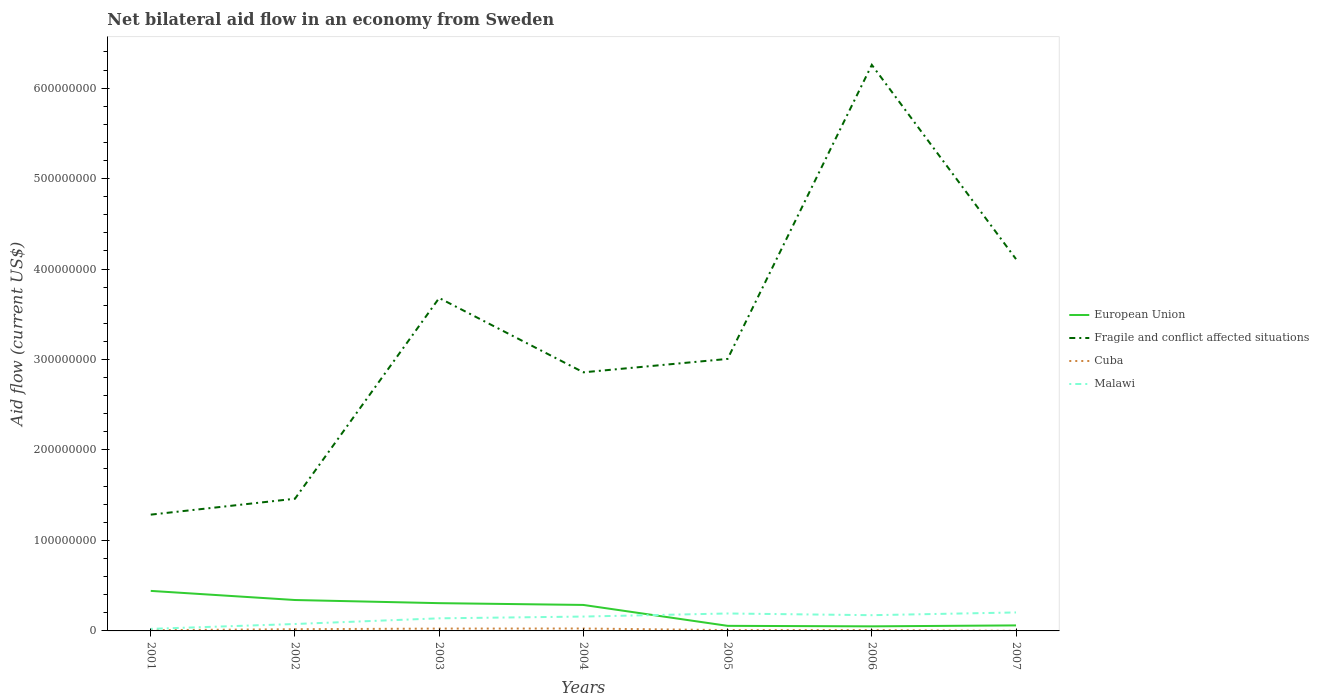Does the line corresponding to Fragile and conflict affected situations intersect with the line corresponding to European Union?
Keep it short and to the point. No. Across all years, what is the maximum net bilateral aid flow in European Union?
Offer a very short reply. 5.06e+06. In which year was the net bilateral aid flow in Cuba maximum?
Your answer should be compact. 2007. What is the total net bilateral aid flow in Cuba in the graph?
Provide a succinct answer. 1.74e+06. What is the difference between the highest and the second highest net bilateral aid flow in European Union?
Make the answer very short. 3.92e+07. What is the difference between the highest and the lowest net bilateral aid flow in Malawi?
Offer a terse response. 5. How many lines are there?
Your answer should be very brief. 4. Are the values on the major ticks of Y-axis written in scientific E-notation?
Offer a terse response. No. Does the graph contain any zero values?
Your response must be concise. No. Does the graph contain grids?
Offer a terse response. No. Where does the legend appear in the graph?
Offer a terse response. Center right. What is the title of the graph?
Offer a very short reply. Net bilateral aid flow in an economy from Sweden. Does "Andorra" appear as one of the legend labels in the graph?
Make the answer very short. No. What is the Aid flow (current US$) in European Union in 2001?
Give a very brief answer. 4.42e+07. What is the Aid flow (current US$) of Fragile and conflict affected situations in 2001?
Keep it short and to the point. 1.29e+08. What is the Aid flow (current US$) of Cuba in 2001?
Your response must be concise. 8.10e+05. What is the Aid flow (current US$) of Malawi in 2001?
Give a very brief answer. 2.27e+06. What is the Aid flow (current US$) of European Union in 2002?
Ensure brevity in your answer.  3.42e+07. What is the Aid flow (current US$) in Fragile and conflict affected situations in 2002?
Ensure brevity in your answer.  1.46e+08. What is the Aid flow (current US$) of Cuba in 2002?
Offer a very short reply. 1.89e+06. What is the Aid flow (current US$) of Malawi in 2002?
Offer a very short reply. 7.65e+06. What is the Aid flow (current US$) in European Union in 2003?
Your response must be concise. 3.07e+07. What is the Aid flow (current US$) of Fragile and conflict affected situations in 2003?
Keep it short and to the point. 3.68e+08. What is the Aid flow (current US$) in Cuba in 2003?
Your answer should be compact. 2.58e+06. What is the Aid flow (current US$) of Malawi in 2003?
Your answer should be compact. 1.39e+07. What is the Aid flow (current US$) in European Union in 2004?
Your response must be concise. 2.87e+07. What is the Aid flow (current US$) in Fragile and conflict affected situations in 2004?
Your response must be concise. 2.86e+08. What is the Aid flow (current US$) of Cuba in 2004?
Your answer should be compact. 2.66e+06. What is the Aid flow (current US$) of Malawi in 2004?
Provide a succinct answer. 1.59e+07. What is the Aid flow (current US$) in European Union in 2005?
Your response must be concise. 5.62e+06. What is the Aid flow (current US$) in Fragile and conflict affected situations in 2005?
Your answer should be very brief. 3.01e+08. What is the Aid flow (current US$) in Cuba in 2005?
Offer a terse response. 9.30e+05. What is the Aid flow (current US$) of Malawi in 2005?
Make the answer very short. 1.93e+07. What is the Aid flow (current US$) of European Union in 2006?
Your answer should be compact. 5.06e+06. What is the Aid flow (current US$) of Fragile and conflict affected situations in 2006?
Make the answer very short. 6.26e+08. What is the Aid flow (current US$) of Cuba in 2006?
Offer a very short reply. 9.20e+05. What is the Aid flow (current US$) of Malawi in 2006?
Your answer should be compact. 1.74e+07. What is the Aid flow (current US$) in European Union in 2007?
Keep it short and to the point. 6.10e+06. What is the Aid flow (current US$) of Fragile and conflict affected situations in 2007?
Your answer should be very brief. 4.11e+08. What is the Aid flow (current US$) in Cuba in 2007?
Provide a succinct answer. 1.10e+05. What is the Aid flow (current US$) in Malawi in 2007?
Keep it short and to the point. 2.04e+07. Across all years, what is the maximum Aid flow (current US$) in European Union?
Ensure brevity in your answer.  4.42e+07. Across all years, what is the maximum Aid flow (current US$) in Fragile and conflict affected situations?
Your response must be concise. 6.26e+08. Across all years, what is the maximum Aid flow (current US$) in Cuba?
Ensure brevity in your answer.  2.66e+06. Across all years, what is the maximum Aid flow (current US$) of Malawi?
Your response must be concise. 2.04e+07. Across all years, what is the minimum Aid flow (current US$) of European Union?
Give a very brief answer. 5.06e+06. Across all years, what is the minimum Aid flow (current US$) of Fragile and conflict affected situations?
Provide a succinct answer. 1.29e+08. Across all years, what is the minimum Aid flow (current US$) in Malawi?
Your answer should be very brief. 2.27e+06. What is the total Aid flow (current US$) in European Union in the graph?
Make the answer very short. 1.55e+08. What is the total Aid flow (current US$) of Fragile and conflict affected situations in the graph?
Ensure brevity in your answer.  2.27e+09. What is the total Aid flow (current US$) of Cuba in the graph?
Offer a very short reply. 9.90e+06. What is the total Aid flow (current US$) in Malawi in the graph?
Provide a succinct answer. 9.68e+07. What is the difference between the Aid flow (current US$) of European Union in 2001 and that in 2002?
Ensure brevity in your answer.  1.01e+07. What is the difference between the Aid flow (current US$) in Fragile and conflict affected situations in 2001 and that in 2002?
Ensure brevity in your answer.  -1.76e+07. What is the difference between the Aid flow (current US$) of Cuba in 2001 and that in 2002?
Ensure brevity in your answer.  -1.08e+06. What is the difference between the Aid flow (current US$) of Malawi in 2001 and that in 2002?
Your answer should be compact. -5.38e+06. What is the difference between the Aid flow (current US$) in European Union in 2001 and that in 2003?
Give a very brief answer. 1.36e+07. What is the difference between the Aid flow (current US$) of Fragile and conflict affected situations in 2001 and that in 2003?
Offer a very short reply. -2.39e+08. What is the difference between the Aid flow (current US$) in Cuba in 2001 and that in 2003?
Keep it short and to the point. -1.77e+06. What is the difference between the Aid flow (current US$) in Malawi in 2001 and that in 2003?
Make the answer very short. -1.17e+07. What is the difference between the Aid flow (current US$) in European Union in 2001 and that in 2004?
Ensure brevity in your answer.  1.55e+07. What is the difference between the Aid flow (current US$) in Fragile and conflict affected situations in 2001 and that in 2004?
Your answer should be very brief. -1.57e+08. What is the difference between the Aid flow (current US$) of Cuba in 2001 and that in 2004?
Offer a terse response. -1.85e+06. What is the difference between the Aid flow (current US$) in Malawi in 2001 and that in 2004?
Keep it short and to the point. -1.36e+07. What is the difference between the Aid flow (current US$) of European Union in 2001 and that in 2005?
Your answer should be very brief. 3.86e+07. What is the difference between the Aid flow (current US$) in Fragile and conflict affected situations in 2001 and that in 2005?
Provide a succinct answer. -1.72e+08. What is the difference between the Aid flow (current US$) of Cuba in 2001 and that in 2005?
Make the answer very short. -1.20e+05. What is the difference between the Aid flow (current US$) in Malawi in 2001 and that in 2005?
Give a very brief answer. -1.70e+07. What is the difference between the Aid flow (current US$) of European Union in 2001 and that in 2006?
Offer a very short reply. 3.92e+07. What is the difference between the Aid flow (current US$) in Fragile and conflict affected situations in 2001 and that in 2006?
Offer a very short reply. -4.97e+08. What is the difference between the Aid flow (current US$) of Cuba in 2001 and that in 2006?
Provide a short and direct response. -1.10e+05. What is the difference between the Aid flow (current US$) in Malawi in 2001 and that in 2006?
Your answer should be compact. -1.51e+07. What is the difference between the Aid flow (current US$) of European Union in 2001 and that in 2007?
Offer a very short reply. 3.82e+07. What is the difference between the Aid flow (current US$) in Fragile and conflict affected situations in 2001 and that in 2007?
Offer a terse response. -2.82e+08. What is the difference between the Aid flow (current US$) of Malawi in 2001 and that in 2007?
Give a very brief answer. -1.82e+07. What is the difference between the Aid flow (current US$) of European Union in 2002 and that in 2003?
Your answer should be compact. 3.47e+06. What is the difference between the Aid flow (current US$) of Fragile and conflict affected situations in 2002 and that in 2003?
Keep it short and to the point. -2.22e+08. What is the difference between the Aid flow (current US$) of Cuba in 2002 and that in 2003?
Offer a very short reply. -6.90e+05. What is the difference between the Aid flow (current US$) in Malawi in 2002 and that in 2003?
Your answer should be very brief. -6.28e+06. What is the difference between the Aid flow (current US$) of European Union in 2002 and that in 2004?
Make the answer very short. 5.45e+06. What is the difference between the Aid flow (current US$) in Fragile and conflict affected situations in 2002 and that in 2004?
Give a very brief answer. -1.40e+08. What is the difference between the Aid flow (current US$) in Cuba in 2002 and that in 2004?
Your answer should be compact. -7.70e+05. What is the difference between the Aid flow (current US$) in Malawi in 2002 and that in 2004?
Provide a succinct answer. -8.23e+06. What is the difference between the Aid flow (current US$) in European Union in 2002 and that in 2005?
Offer a terse response. 2.86e+07. What is the difference between the Aid flow (current US$) in Fragile and conflict affected situations in 2002 and that in 2005?
Provide a succinct answer. -1.55e+08. What is the difference between the Aid flow (current US$) of Cuba in 2002 and that in 2005?
Ensure brevity in your answer.  9.60e+05. What is the difference between the Aid flow (current US$) of Malawi in 2002 and that in 2005?
Provide a succinct answer. -1.16e+07. What is the difference between the Aid flow (current US$) in European Union in 2002 and that in 2006?
Make the answer very short. 2.91e+07. What is the difference between the Aid flow (current US$) of Fragile and conflict affected situations in 2002 and that in 2006?
Offer a terse response. -4.80e+08. What is the difference between the Aid flow (current US$) of Cuba in 2002 and that in 2006?
Your answer should be compact. 9.70e+05. What is the difference between the Aid flow (current US$) of Malawi in 2002 and that in 2006?
Provide a succinct answer. -9.74e+06. What is the difference between the Aid flow (current US$) in European Union in 2002 and that in 2007?
Provide a short and direct response. 2.81e+07. What is the difference between the Aid flow (current US$) of Fragile and conflict affected situations in 2002 and that in 2007?
Your answer should be very brief. -2.65e+08. What is the difference between the Aid flow (current US$) in Cuba in 2002 and that in 2007?
Provide a succinct answer. 1.78e+06. What is the difference between the Aid flow (current US$) in Malawi in 2002 and that in 2007?
Offer a very short reply. -1.28e+07. What is the difference between the Aid flow (current US$) in European Union in 2003 and that in 2004?
Offer a terse response. 1.98e+06. What is the difference between the Aid flow (current US$) in Fragile and conflict affected situations in 2003 and that in 2004?
Your answer should be very brief. 8.22e+07. What is the difference between the Aid flow (current US$) of Cuba in 2003 and that in 2004?
Your answer should be compact. -8.00e+04. What is the difference between the Aid flow (current US$) of Malawi in 2003 and that in 2004?
Offer a very short reply. -1.95e+06. What is the difference between the Aid flow (current US$) in European Union in 2003 and that in 2005?
Give a very brief answer. 2.51e+07. What is the difference between the Aid flow (current US$) in Fragile and conflict affected situations in 2003 and that in 2005?
Provide a succinct answer. 6.73e+07. What is the difference between the Aid flow (current US$) in Cuba in 2003 and that in 2005?
Your response must be concise. 1.65e+06. What is the difference between the Aid flow (current US$) of Malawi in 2003 and that in 2005?
Offer a terse response. -5.35e+06. What is the difference between the Aid flow (current US$) of European Union in 2003 and that in 2006?
Provide a short and direct response. 2.56e+07. What is the difference between the Aid flow (current US$) of Fragile and conflict affected situations in 2003 and that in 2006?
Offer a terse response. -2.58e+08. What is the difference between the Aid flow (current US$) of Cuba in 2003 and that in 2006?
Make the answer very short. 1.66e+06. What is the difference between the Aid flow (current US$) in Malawi in 2003 and that in 2006?
Ensure brevity in your answer.  -3.46e+06. What is the difference between the Aid flow (current US$) in European Union in 2003 and that in 2007?
Your response must be concise. 2.46e+07. What is the difference between the Aid flow (current US$) in Fragile and conflict affected situations in 2003 and that in 2007?
Provide a succinct answer. -4.30e+07. What is the difference between the Aid flow (current US$) in Cuba in 2003 and that in 2007?
Your answer should be compact. 2.47e+06. What is the difference between the Aid flow (current US$) in Malawi in 2003 and that in 2007?
Your response must be concise. -6.49e+06. What is the difference between the Aid flow (current US$) in European Union in 2004 and that in 2005?
Provide a short and direct response. 2.31e+07. What is the difference between the Aid flow (current US$) in Fragile and conflict affected situations in 2004 and that in 2005?
Your answer should be very brief. -1.48e+07. What is the difference between the Aid flow (current US$) of Cuba in 2004 and that in 2005?
Your answer should be compact. 1.73e+06. What is the difference between the Aid flow (current US$) in Malawi in 2004 and that in 2005?
Your answer should be very brief. -3.40e+06. What is the difference between the Aid flow (current US$) in European Union in 2004 and that in 2006?
Provide a short and direct response. 2.37e+07. What is the difference between the Aid flow (current US$) in Fragile and conflict affected situations in 2004 and that in 2006?
Ensure brevity in your answer.  -3.40e+08. What is the difference between the Aid flow (current US$) of Cuba in 2004 and that in 2006?
Your response must be concise. 1.74e+06. What is the difference between the Aid flow (current US$) in Malawi in 2004 and that in 2006?
Ensure brevity in your answer.  -1.51e+06. What is the difference between the Aid flow (current US$) of European Union in 2004 and that in 2007?
Provide a short and direct response. 2.26e+07. What is the difference between the Aid flow (current US$) in Fragile and conflict affected situations in 2004 and that in 2007?
Make the answer very short. -1.25e+08. What is the difference between the Aid flow (current US$) in Cuba in 2004 and that in 2007?
Give a very brief answer. 2.55e+06. What is the difference between the Aid flow (current US$) in Malawi in 2004 and that in 2007?
Provide a succinct answer. -4.54e+06. What is the difference between the Aid flow (current US$) in European Union in 2005 and that in 2006?
Keep it short and to the point. 5.60e+05. What is the difference between the Aid flow (current US$) of Fragile and conflict affected situations in 2005 and that in 2006?
Ensure brevity in your answer.  -3.25e+08. What is the difference between the Aid flow (current US$) in Cuba in 2005 and that in 2006?
Provide a succinct answer. 10000. What is the difference between the Aid flow (current US$) of Malawi in 2005 and that in 2006?
Provide a succinct answer. 1.89e+06. What is the difference between the Aid flow (current US$) in European Union in 2005 and that in 2007?
Keep it short and to the point. -4.80e+05. What is the difference between the Aid flow (current US$) of Fragile and conflict affected situations in 2005 and that in 2007?
Offer a very short reply. -1.10e+08. What is the difference between the Aid flow (current US$) in Cuba in 2005 and that in 2007?
Make the answer very short. 8.20e+05. What is the difference between the Aid flow (current US$) in Malawi in 2005 and that in 2007?
Provide a short and direct response. -1.14e+06. What is the difference between the Aid flow (current US$) of European Union in 2006 and that in 2007?
Make the answer very short. -1.04e+06. What is the difference between the Aid flow (current US$) of Fragile and conflict affected situations in 2006 and that in 2007?
Your answer should be very brief. 2.15e+08. What is the difference between the Aid flow (current US$) in Cuba in 2006 and that in 2007?
Ensure brevity in your answer.  8.10e+05. What is the difference between the Aid flow (current US$) of Malawi in 2006 and that in 2007?
Keep it short and to the point. -3.03e+06. What is the difference between the Aid flow (current US$) of European Union in 2001 and the Aid flow (current US$) of Fragile and conflict affected situations in 2002?
Make the answer very short. -1.02e+08. What is the difference between the Aid flow (current US$) in European Union in 2001 and the Aid flow (current US$) in Cuba in 2002?
Your response must be concise. 4.24e+07. What is the difference between the Aid flow (current US$) of European Union in 2001 and the Aid flow (current US$) of Malawi in 2002?
Give a very brief answer. 3.66e+07. What is the difference between the Aid flow (current US$) in Fragile and conflict affected situations in 2001 and the Aid flow (current US$) in Cuba in 2002?
Ensure brevity in your answer.  1.27e+08. What is the difference between the Aid flow (current US$) of Fragile and conflict affected situations in 2001 and the Aid flow (current US$) of Malawi in 2002?
Your answer should be very brief. 1.21e+08. What is the difference between the Aid flow (current US$) in Cuba in 2001 and the Aid flow (current US$) in Malawi in 2002?
Make the answer very short. -6.84e+06. What is the difference between the Aid flow (current US$) of European Union in 2001 and the Aid flow (current US$) of Fragile and conflict affected situations in 2003?
Ensure brevity in your answer.  -3.24e+08. What is the difference between the Aid flow (current US$) in European Union in 2001 and the Aid flow (current US$) in Cuba in 2003?
Give a very brief answer. 4.17e+07. What is the difference between the Aid flow (current US$) in European Union in 2001 and the Aid flow (current US$) in Malawi in 2003?
Offer a terse response. 3.03e+07. What is the difference between the Aid flow (current US$) of Fragile and conflict affected situations in 2001 and the Aid flow (current US$) of Cuba in 2003?
Provide a short and direct response. 1.26e+08. What is the difference between the Aid flow (current US$) in Fragile and conflict affected situations in 2001 and the Aid flow (current US$) in Malawi in 2003?
Your response must be concise. 1.15e+08. What is the difference between the Aid flow (current US$) of Cuba in 2001 and the Aid flow (current US$) of Malawi in 2003?
Your answer should be compact. -1.31e+07. What is the difference between the Aid flow (current US$) of European Union in 2001 and the Aid flow (current US$) of Fragile and conflict affected situations in 2004?
Your response must be concise. -2.42e+08. What is the difference between the Aid flow (current US$) of European Union in 2001 and the Aid flow (current US$) of Cuba in 2004?
Your response must be concise. 4.16e+07. What is the difference between the Aid flow (current US$) in European Union in 2001 and the Aid flow (current US$) in Malawi in 2004?
Provide a succinct answer. 2.84e+07. What is the difference between the Aid flow (current US$) of Fragile and conflict affected situations in 2001 and the Aid flow (current US$) of Cuba in 2004?
Provide a short and direct response. 1.26e+08. What is the difference between the Aid flow (current US$) of Fragile and conflict affected situations in 2001 and the Aid flow (current US$) of Malawi in 2004?
Your response must be concise. 1.13e+08. What is the difference between the Aid flow (current US$) in Cuba in 2001 and the Aid flow (current US$) in Malawi in 2004?
Offer a very short reply. -1.51e+07. What is the difference between the Aid flow (current US$) in European Union in 2001 and the Aid flow (current US$) in Fragile and conflict affected situations in 2005?
Make the answer very short. -2.56e+08. What is the difference between the Aid flow (current US$) of European Union in 2001 and the Aid flow (current US$) of Cuba in 2005?
Make the answer very short. 4.33e+07. What is the difference between the Aid flow (current US$) in European Union in 2001 and the Aid flow (current US$) in Malawi in 2005?
Ensure brevity in your answer.  2.50e+07. What is the difference between the Aid flow (current US$) in Fragile and conflict affected situations in 2001 and the Aid flow (current US$) in Cuba in 2005?
Your answer should be very brief. 1.28e+08. What is the difference between the Aid flow (current US$) in Fragile and conflict affected situations in 2001 and the Aid flow (current US$) in Malawi in 2005?
Provide a short and direct response. 1.09e+08. What is the difference between the Aid flow (current US$) in Cuba in 2001 and the Aid flow (current US$) in Malawi in 2005?
Provide a short and direct response. -1.85e+07. What is the difference between the Aid flow (current US$) in European Union in 2001 and the Aid flow (current US$) in Fragile and conflict affected situations in 2006?
Ensure brevity in your answer.  -5.81e+08. What is the difference between the Aid flow (current US$) in European Union in 2001 and the Aid flow (current US$) in Cuba in 2006?
Your answer should be very brief. 4.33e+07. What is the difference between the Aid flow (current US$) of European Union in 2001 and the Aid flow (current US$) of Malawi in 2006?
Provide a succinct answer. 2.69e+07. What is the difference between the Aid flow (current US$) in Fragile and conflict affected situations in 2001 and the Aid flow (current US$) in Cuba in 2006?
Provide a short and direct response. 1.28e+08. What is the difference between the Aid flow (current US$) of Fragile and conflict affected situations in 2001 and the Aid flow (current US$) of Malawi in 2006?
Offer a very short reply. 1.11e+08. What is the difference between the Aid flow (current US$) of Cuba in 2001 and the Aid flow (current US$) of Malawi in 2006?
Make the answer very short. -1.66e+07. What is the difference between the Aid flow (current US$) of European Union in 2001 and the Aid flow (current US$) of Fragile and conflict affected situations in 2007?
Offer a very short reply. -3.67e+08. What is the difference between the Aid flow (current US$) of European Union in 2001 and the Aid flow (current US$) of Cuba in 2007?
Your response must be concise. 4.41e+07. What is the difference between the Aid flow (current US$) of European Union in 2001 and the Aid flow (current US$) of Malawi in 2007?
Offer a terse response. 2.38e+07. What is the difference between the Aid flow (current US$) in Fragile and conflict affected situations in 2001 and the Aid flow (current US$) in Cuba in 2007?
Your response must be concise. 1.28e+08. What is the difference between the Aid flow (current US$) of Fragile and conflict affected situations in 2001 and the Aid flow (current US$) of Malawi in 2007?
Provide a succinct answer. 1.08e+08. What is the difference between the Aid flow (current US$) of Cuba in 2001 and the Aid flow (current US$) of Malawi in 2007?
Your answer should be very brief. -1.96e+07. What is the difference between the Aid flow (current US$) in European Union in 2002 and the Aid flow (current US$) in Fragile and conflict affected situations in 2003?
Ensure brevity in your answer.  -3.34e+08. What is the difference between the Aid flow (current US$) of European Union in 2002 and the Aid flow (current US$) of Cuba in 2003?
Provide a short and direct response. 3.16e+07. What is the difference between the Aid flow (current US$) in European Union in 2002 and the Aid flow (current US$) in Malawi in 2003?
Your answer should be compact. 2.02e+07. What is the difference between the Aid flow (current US$) in Fragile and conflict affected situations in 2002 and the Aid flow (current US$) in Cuba in 2003?
Your answer should be very brief. 1.44e+08. What is the difference between the Aid flow (current US$) in Fragile and conflict affected situations in 2002 and the Aid flow (current US$) in Malawi in 2003?
Your response must be concise. 1.32e+08. What is the difference between the Aid flow (current US$) in Cuba in 2002 and the Aid flow (current US$) in Malawi in 2003?
Your answer should be compact. -1.20e+07. What is the difference between the Aid flow (current US$) in European Union in 2002 and the Aid flow (current US$) in Fragile and conflict affected situations in 2004?
Provide a short and direct response. -2.52e+08. What is the difference between the Aid flow (current US$) of European Union in 2002 and the Aid flow (current US$) of Cuba in 2004?
Provide a succinct answer. 3.15e+07. What is the difference between the Aid flow (current US$) of European Union in 2002 and the Aid flow (current US$) of Malawi in 2004?
Keep it short and to the point. 1.83e+07. What is the difference between the Aid flow (current US$) of Fragile and conflict affected situations in 2002 and the Aid flow (current US$) of Cuba in 2004?
Provide a succinct answer. 1.43e+08. What is the difference between the Aid flow (current US$) of Fragile and conflict affected situations in 2002 and the Aid flow (current US$) of Malawi in 2004?
Ensure brevity in your answer.  1.30e+08. What is the difference between the Aid flow (current US$) in Cuba in 2002 and the Aid flow (current US$) in Malawi in 2004?
Your answer should be very brief. -1.40e+07. What is the difference between the Aid flow (current US$) of European Union in 2002 and the Aid flow (current US$) of Fragile and conflict affected situations in 2005?
Give a very brief answer. -2.67e+08. What is the difference between the Aid flow (current US$) of European Union in 2002 and the Aid flow (current US$) of Cuba in 2005?
Your response must be concise. 3.32e+07. What is the difference between the Aid flow (current US$) in European Union in 2002 and the Aid flow (current US$) in Malawi in 2005?
Offer a terse response. 1.49e+07. What is the difference between the Aid flow (current US$) in Fragile and conflict affected situations in 2002 and the Aid flow (current US$) in Cuba in 2005?
Offer a terse response. 1.45e+08. What is the difference between the Aid flow (current US$) of Fragile and conflict affected situations in 2002 and the Aid flow (current US$) of Malawi in 2005?
Your answer should be compact. 1.27e+08. What is the difference between the Aid flow (current US$) in Cuba in 2002 and the Aid flow (current US$) in Malawi in 2005?
Keep it short and to the point. -1.74e+07. What is the difference between the Aid flow (current US$) of European Union in 2002 and the Aid flow (current US$) of Fragile and conflict affected situations in 2006?
Your answer should be compact. -5.92e+08. What is the difference between the Aid flow (current US$) of European Union in 2002 and the Aid flow (current US$) of Cuba in 2006?
Your answer should be very brief. 3.32e+07. What is the difference between the Aid flow (current US$) of European Union in 2002 and the Aid flow (current US$) of Malawi in 2006?
Give a very brief answer. 1.68e+07. What is the difference between the Aid flow (current US$) of Fragile and conflict affected situations in 2002 and the Aid flow (current US$) of Cuba in 2006?
Provide a short and direct response. 1.45e+08. What is the difference between the Aid flow (current US$) in Fragile and conflict affected situations in 2002 and the Aid flow (current US$) in Malawi in 2006?
Ensure brevity in your answer.  1.29e+08. What is the difference between the Aid flow (current US$) of Cuba in 2002 and the Aid flow (current US$) of Malawi in 2006?
Make the answer very short. -1.55e+07. What is the difference between the Aid flow (current US$) in European Union in 2002 and the Aid flow (current US$) in Fragile and conflict affected situations in 2007?
Provide a short and direct response. -3.77e+08. What is the difference between the Aid flow (current US$) of European Union in 2002 and the Aid flow (current US$) of Cuba in 2007?
Your answer should be very brief. 3.41e+07. What is the difference between the Aid flow (current US$) of European Union in 2002 and the Aid flow (current US$) of Malawi in 2007?
Your answer should be very brief. 1.38e+07. What is the difference between the Aid flow (current US$) in Fragile and conflict affected situations in 2002 and the Aid flow (current US$) in Cuba in 2007?
Ensure brevity in your answer.  1.46e+08. What is the difference between the Aid flow (current US$) in Fragile and conflict affected situations in 2002 and the Aid flow (current US$) in Malawi in 2007?
Your response must be concise. 1.26e+08. What is the difference between the Aid flow (current US$) in Cuba in 2002 and the Aid flow (current US$) in Malawi in 2007?
Your answer should be very brief. -1.85e+07. What is the difference between the Aid flow (current US$) in European Union in 2003 and the Aid flow (current US$) in Fragile and conflict affected situations in 2004?
Your answer should be compact. -2.55e+08. What is the difference between the Aid flow (current US$) in European Union in 2003 and the Aid flow (current US$) in Cuba in 2004?
Provide a short and direct response. 2.80e+07. What is the difference between the Aid flow (current US$) of European Union in 2003 and the Aid flow (current US$) of Malawi in 2004?
Keep it short and to the point. 1.48e+07. What is the difference between the Aid flow (current US$) of Fragile and conflict affected situations in 2003 and the Aid flow (current US$) of Cuba in 2004?
Your answer should be very brief. 3.65e+08. What is the difference between the Aid flow (current US$) in Fragile and conflict affected situations in 2003 and the Aid flow (current US$) in Malawi in 2004?
Provide a short and direct response. 3.52e+08. What is the difference between the Aid flow (current US$) of Cuba in 2003 and the Aid flow (current US$) of Malawi in 2004?
Provide a succinct answer. -1.33e+07. What is the difference between the Aid flow (current US$) of European Union in 2003 and the Aid flow (current US$) of Fragile and conflict affected situations in 2005?
Provide a succinct answer. -2.70e+08. What is the difference between the Aid flow (current US$) in European Union in 2003 and the Aid flow (current US$) in Cuba in 2005?
Offer a terse response. 2.98e+07. What is the difference between the Aid flow (current US$) of European Union in 2003 and the Aid flow (current US$) of Malawi in 2005?
Give a very brief answer. 1.14e+07. What is the difference between the Aid flow (current US$) in Fragile and conflict affected situations in 2003 and the Aid flow (current US$) in Cuba in 2005?
Your answer should be very brief. 3.67e+08. What is the difference between the Aid flow (current US$) of Fragile and conflict affected situations in 2003 and the Aid flow (current US$) of Malawi in 2005?
Give a very brief answer. 3.49e+08. What is the difference between the Aid flow (current US$) in Cuba in 2003 and the Aid flow (current US$) in Malawi in 2005?
Ensure brevity in your answer.  -1.67e+07. What is the difference between the Aid flow (current US$) in European Union in 2003 and the Aid flow (current US$) in Fragile and conflict affected situations in 2006?
Offer a terse response. -5.95e+08. What is the difference between the Aid flow (current US$) in European Union in 2003 and the Aid flow (current US$) in Cuba in 2006?
Your answer should be very brief. 2.98e+07. What is the difference between the Aid flow (current US$) in European Union in 2003 and the Aid flow (current US$) in Malawi in 2006?
Provide a short and direct response. 1.33e+07. What is the difference between the Aid flow (current US$) of Fragile and conflict affected situations in 2003 and the Aid flow (current US$) of Cuba in 2006?
Keep it short and to the point. 3.67e+08. What is the difference between the Aid flow (current US$) of Fragile and conflict affected situations in 2003 and the Aid flow (current US$) of Malawi in 2006?
Make the answer very short. 3.51e+08. What is the difference between the Aid flow (current US$) in Cuba in 2003 and the Aid flow (current US$) in Malawi in 2006?
Your answer should be compact. -1.48e+07. What is the difference between the Aid flow (current US$) of European Union in 2003 and the Aid flow (current US$) of Fragile and conflict affected situations in 2007?
Your response must be concise. -3.80e+08. What is the difference between the Aid flow (current US$) in European Union in 2003 and the Aid flow (current US$) in Cuba in 2007?
Your answer should be very brief. 3.06e+07. What is the difference between the Aid flow (current US$) of European Union in 2003 and the Aid flow (current US$) of Malawi in 2007?
Ensure brevity in your answer.  1.03e+07. What is the difference between the Aid flow (current US$) in Fragile and conflict affected situations in 2003 and the Aid flow (current US$) in Cuba in 2007?
Keep it short and to the point. 3.68e+08. What is the difference between the Aid flow (current US$) of Fragile and conflict affected situations in 2003 and the Aid flow (current US$) of Malawi in 2007?
Your response must be concise. 3.48e+08. What is the difference between the Aid flow (current US$) in Cuba in 2003 and the Aid flow (current US$) in Malawi in 2007?
Your response must be concise. -1.78e+07. What is the difference between the Aid flow (current US$) in European Union in 2004 and the Aid flow (current US$) in Fragile and conflict affected situations in 2005?
Offer a very short reply. -2.72e+08. What is the difference between the Aid flow (current US$) of European Union in 2004 and the Aid flow (current US$) of Cuba in 2005?
Provide a succinct answer. 2.78e+07. What is the difference between the Aid flow (current US$) of European Union in 2004 and the Aid flow (current US$) of Malawi in 2005?
Provide a short and direct response. 9.44e+06. What is the difference between the Aid flow (current US$) of Fragile and conflict affected situations in 2004 and the Aid flow (current US$) of Cuba in 2005?
Keep it short and to the point. 2.85e+08. What is the difference between the Aid flow (current US$) in Fragile and conflict affected situations in 2004 and the Aid flow (current US$) in Malawi in 2005?
Make the answer very short. 2.67e+08. What is the difference between the Aid flow (current US$) of Cuba in 2004 and the Aid flow (current US$) of Malawi in 2005?
Offer a terse response. -1.66e+07. What is the difference between the Aid flow (current US$) of European Union in 2004 and the Aid flow (current US$) of Fragile and conflict affected situations in 2006?
Your answer should be very brief. -5.97e+08. What is the difference between the Aid flow (current US$) in European Union in 2004 and the Aid flow (current US$) in Cuba in 2006?
Your response must be concise. 2.78e+07. What is the difference between the Aid flow (current US$) in European Union in 2004 and the Aid flow (current US$) in Malawi in 2006?
Provide a short and direct response. 1.13e+07. What is the difference between the Aid flow (current US$) in Fragile and conflict affected situations in 2004 and the Aid flow (current US$) in Cuba in 2006?
Provide a short and direct response. 2.85e+08. What is the difference between the Aid flow (current US$) in Fragile and conflict affected situations in 2004 and the Aid flow (current US$) in Malawi in 2006?
Keep it short and to the point. 2.68e+08. What is the difference between the Aid flow (current US$) of Cuba in 2004 and the Aid flow (current US$) of Malawi in 2006?
Your response must be concise. -1.47e+07. What is the difference between the Aid flow (current US$) in European Union in 2004 and the Aid flow (current US$) in Fragile and conflict affected situations in 2007?
Offer a terse response. -3.82e+08. What is the difference between the Aid flow (current US$) in European Union in 2004 and the Aid flow (current US$) in Cuba in 2007?
Your answer should be compact. 2.86e+07. What is the difference between the Aid flow (current US$) of European Union in 2004 and the Aid flow (current US$) of Malawi in 2007?
Keep it short and to the point. 8.30e+06. What is the difference between the Aid flow (current US$) of Fragile and conflict affected situations in 2004 and the Aid flow (current US$) of Cuba in 2007?
Your answer should be very brief. 2.86e+08. What is the difference between the Aid flow (current US$) in Fragile and conflict affected situations in 2004 and the Aid flow (current US$) in Malawi in 2007?
Your answer should be very brief. 2.65e+08. What is the difference between the Aid flow (current US$) of Cuba in 2004 and the Aid flow (current US$) of Malawi in 2007?
Keep it short and to the point. -1.78e+07. What is the difference between the Aid flow (current US$) of European Union in 2005 and the Aid flow (current US$) of Fragile and conflict affected situations in 2006?
Offer a very short reply. -6.20e+08. What is the difference between the Aid flow (current US$) of European Union in 2005 and the Aid flow (current US$) of Cuba in 2006?
Provide a succinct answer. 4.70e+06. What is the difference between the Aid flow (current US$) of European Union in 2005 and the Aid flow (current US$) of Malawi in 2006?
Offer a terse response. -1.18e+07. What is the difference between the Aid flow (current US$) in Fragile and conflict affected situations in 2005 and the Aid flow (current US$) in Cuba in 2006?
Provide a succinct answer. 3.00e+08. What is the difference between the Aid flow (current US$) of Fragile and conflict affected situations in 2005 and the Aid flow (current US$) of Malawi in 2006?
Your answer should be very brief. 2.83e+08. What is the difference between the Aid flow (current US$) in Cuba in 2005 and the Aid flow (current US$) in Malawi in 2006?
Offer a terse response. -1.65e+07. What is the difference between the Aid flow (current US$) of European Union in 2005 and the Aid flow (current US$) of Fragile and conflict affected situations in 2007?
Your answer should be compact. -4.05e+08. What is the difference between the Aid flow (current US$) in European Union in 2005 and the Aid flow (current US$) in Cuba in 2007?
Your answer should be compact. 5.51e+06. What is the difference between the Aid flow (current US$) in European Union in 2005 and the Aid flow (current US$) in Malawi in 2007?
Your response must be concise. -1.48e+07. What is the difference between the Aid flow (current US$) in Fragile and conflict affected situations in 2005 and the Aid flow (current US$) in Cuba in 2007?
Your response must be concise. 3.01e+08. What is the difference between the Aid flow (current US$) of Fragile and conflict affected situations in 2005 and the Aid flow (current US$) of Malawi in 2007?
Your answer should be very brief. 2.80e+08. What is the difference between the Aid flow (current US$) of Cuba in 2005 and the Aid flow (current US$) of Malawi in 2007?
Keep it short and to the point. -1.95e+07. What is the difference between the Aid flow (current US$) of European Union in 2006 and the Aid flow (current US$) of Fragile and conflict affected situations in 2007?
Your response must be concise. -4.06e+08. What is the difference between the Aid flow (current US$) of European Union in 2006 and the Aid flow (current US$) of Cuba in 2007?
Offer a very short reply. 4.95e+06. What is the difference between the Aid flow (current US$) of European Union in 2006 and the Aid flow (current US$) of Malawi in 2007?
Make the answer very short. -1.54e+07. What is the difference between the Aid flow (current US$) of Fragile and conflict affected situations in 2006 and the Aid flow (current US$) of Cuba in 2007?
Your answer should be compact. 6.26e+08. What is the difference between the Aid flow (current US$) of Fragile and conflict affected situations in 2006 and the Aid flow (current US$) of Malawi in 2007?
Give a very brief answer. 6.05e+08. What is the difference between the Aid flow (current US$) of Cuba in 2006 and the Aid flow (current US$) of Malawi in 2007?
Your answer should be compact. -1.95e+07. What is the average Aid flow (current US$) of European Union per year?
Make the answer very short. 2.21e+07. What is the average Aid flow (current US$) of Fragile and conflict affected situations per year?
Make the answer very short. 3.24e+08. What is the average Aid flow (current US$) of Cuba per year?
Your response must be concise. 1.41e+06. What is the average Aid flow (current US$) in Malawi per year?
Your response must be concise. 1.38e+07. In the year 2001, what is the difference between the Aid flow (current US$) in European Union and Aid flow (current US$) in Fragile and conflict affected situations?
Keep it short and to the point. -8.43e+07. In the year 2001, what is the difference between the Aid flow (current US$) in European Union and Aid flow (current US$) in Cuba?
Your answer should be very brief. 4.34e+07. In the year 2001, what is the difference between the Aid flow (current US$) in European Union and Aid flow (current US$) in Malawi?
Keep it short and to the point. 4.20e+07. In the year 2001, what is the difference between the Aid flow (current US$) of Fragile and conflict affected situations and Aid flow (current US$) of Cuba?
Provide a short and direct response. 1.28e+08. In the year 2001, what is the difference between the Aid flow (current US$) in Fragile and conflict affected situations and Aid flow (current US$) in Malawi?
Provide a succinct answer. 1.26e+08. In the year 2001, what is the difference between the Aid flow (current US$) in Cuba and Aid flow (current US$) in Malawi?
Offer a terse response. -1.46e+06. In the year 2002, what is the difference between the Aid flow (current US$) of European Union and Aid flow (current US$) of Fragile and conflict affected situations?
Make the answer very short. -1.12e+08. In the year 2002, what is the difference between the Aid flow (current US$) in European Union and Aid flow (current US$) in Cuba?
Ensure brevity in your answer.  3.23e+07. In the year 2002, what is the difference between the Aid flow (current US$) of European Union and Aid flow (current US$) of Malawi?
Give a very brief answer. 2.65e+07. In the year 2002, what is the difference between the Aid flow (current US$) in Fragile and conflict affected situations and Aid flow (current US$) in Cuba?
Ensure brevity in your answer.  1.44e+08. In the year 2002, what is the difference between the Aid flow (current US$) of Fragile and conflict affected situations and Aid flow (current US$) of Malawi?
Ensure brevity in your answer.  1.38e+08. In the year 2002, what is the difference between the Aid flow (current US$) of Cuba and Aid flow (current US$) of Malawi?
Provide a short and direct response. -5.76e+06. In the year 2003, what is the difference between the Aid flow (current US$) of European Union and Aid flow (current US$) of Fragile and conflict affected situations?
Offer a very short reply. -3.37e+08. In the year 2003, what is the difference between the Aid flow (current US$) in European Union and Aid flow (current US$) in Cuba?
Offer a terse response. 2.81e+07. In the year 2003, what is the difference between the Aid flow (current US$) in European Union and Aid flow (current US$) in Malawi?
Your answer should be very brief. 1.68e+07. In the year 2003, what is the difference between the Aid flow (current US$) of Fragile and conflict affected situations and Aid flow (current US$) of Cuba?
Give a very brief answer. 3.65e+08. In the year 2003, what is the difference between the Aid flow (current US$) in Fragile and conflict affected situations and Aid flow (current US$) in Malawi?
Your response must be concise. 3.54e+08. In the year 2003, what is the difference between the Aid flow (current US$) in Cuba and Aid flow (current US$) in Malawi?
Offer a very short reply. -1.14e+07. In the year 2004, what is the difference between the Aid flow (current US$) of European Union and Aid flow (current US$) of Fragile and conflict affected situations?
Offer a very short reply. -2.57e+08. In the year 2004, what is the difference between the Aid flow (current US$) of European Union and Aid flow (current US$) of Cuba?
Keep it short and to the point. 2.61e+07. In the year 2004, what is the difference between the Aid flow (current US$) of European Union and Aid flow (current US$) of Malawi?
Provide a succinct answer. 1.28e+07. In the year 2004, what is the difference between the Aid flow (current US$) in Fragile and conflict affected situations and Aid flow (current US$) in Cuba?
Keep it short and to the point. 2.83e+08. In the year 2004, what is the difference between the Aid flow (current US$) of Fragile and conflict affected situations and Aid flow (current US$) of Malawi?
Provide a short and direct response. 2.70e+08. In the year 2004, what is the difference between the Aid flow (current US$) in Cuba and Aid flow (current US$) in Malawi?
Offer a terse response. -1.32e+07. In the year 2005, what is the difference between the Aid flow (current US$) of European Union and Aid flow (current US$) of Fragile and conflict affected situations?
Your answer should be compact. -2.95e+08. In the year 2005, what is the difference between the Aid flow (current US$) in European Union and Aid flow (current US$) in Cuba?
Give a very brief answer. 4.69e+06. In the year 2005, what is the difference between the Aid flow (current US$) of European Union and Aid flow (current US$) of Malawi?
Your response must be concise. -1.37e+07. In the year 2005, what is the difference between the Aid flow (current US$) of Fragile and conflict affected situations and Aid flow (current US$) of Cuba?
Give a very brief answer. 3.00e+08. In the year 2005, what is the difference between the Aid flow (current US$) of Fragile and conflict affected situations and Aid flow (current US$) of Malawi?
Provide a succinct answer. 2.81e+08. In the year 2005, what is the difference between the Aid flow (current US$) in Cuba and Aid flow (current US$) in Malawi?
Keep it short and to the point. -1.84e+07. In the year 2006, what is the difference between the Aid flow (current US$) in European Union and Aid flow (current US$) in Fragile and conflict affected situations?
Your answer should be very brief. -6.21e+08. In the year 2006, what is the difference between the Aid flow (current US$) of European Union and Aid flow (current US$) of Cuba?
Provide a short and direct response. 4.14e+06. In the year 2006, what is the difference between the Aid flow (current US$) of European Union and Aid flow (current US$) of Malawi?
Keep it short and to the point. -1.23e+07. In the year 2006, what is the difference between the Aid flow (current US$) in Fragile and conflict affected situations and Aid flow (current US$) in Cuba?
Your answer should be compact. 6.25e+08. In the year 2006, what is the difference between the Aid flow (current US$) in Fragile and conflict affected situations and Aid flow (current US$) in Malawi?
Your answer should be compact. 6.08e+08. In the year 2006, what is the difference between the Aid flow (current US$) of Cuba and Aid flow (current US$) of Malawi?
Provide a short and direct response. -1.65e+07. In the year 2007, what is the difference between the Aid flow (current US$) in European Union and Aid flow (current US$) in Fragile and conflict affected situations?
Provide a succinct answer. -4.05e+08. In the year 2007, what is the difference between the Aid flow (current US$) of European Union and Aid flow (current US$) of Cuba?
Your answer should be compact. 5.99e+06. In the year 2007, what is the difference between the Aid flow (current US$) in European Union and Aid flow (current US$) in Malawi?
Your response must be concise. -1.43e+07. In the year 2007, what is the difference between the Aid flow (current US$) of Fragile and conflict affected situations and Aid flow (current US$) of Cuba?
Give a very brief answer. 4.11e+08. In the year 2007, what is the difference between the Aid flow (current US$) in Fragile and conflict affected situations and Aid flow (current US$) in Malawi?
Your response must be concise. 3.91e+08. In the year 2007, what is the difference between the Aid flow (current US$) in Cuba and Aid flow (current US$) in Malawi?
Keep it short and to the point. -2.03e+07. What is the ratio of the Aid flow (current US$) in European Union in 2001 to that in 2002?
Your answer should be compact. 1.29. What is the ratio of the Aid flow (current US$) in Fragile and conflict affected situations in 2001 to that in 2002?
Give a very brief answer. 0.88. What is the ratio of the Aid flow (current US$) of Cuba in 2001 to that in 2002?
Make the answer very short. 0.43. What is the ratio of the Aid flow (current US$) in Malawi in 2001 to that in 2002?
Your response must be concise. 0.3. What is the ratio of the Aid flow (current US$) of European Union in 2001 to that in 2003?
Your answer should be compact. 1.44. What is the ratio of the Aid flow (current US$) of Fragile and conflict affected situations in 2001 to that in 2003?
Make the answer very short. 0.35. What is the ratio of the Aid flow (current US$) of Cuba in 2001 to that in 2003?
Ensure brevity in your answer.  0.31. What is the ratio of the Aid flow (current US$) in Malawi in 2001 to that in 2003?
Give a very brief answer. 0.16. What is the ratio of the Aid flow (current US$) of European Union in 2001 to that in 2004?
Your answer should be compact. 1.54. What is the ratio of the Aid flow (current US$) in Fragile and conflict affected situations in 2001 to that in 2004?
Offer a terse response. 0.45. What is the ratio of the Aid flow (current US$) in Cuba in 2001 to that in 2004?
Your answer should be compact. 0.3. What is the ratio of the Aid flow (current US$) in Malawi in 2001 to that in 2004?
Give a very brief answer. 0.14. What is the ratio of the Aid flow (current US$) in European Union in 2001 to that in 2005?
Offer a terse response. 7.87. What is the ratio of the Aid flow (current US$) of Fragile and conflict affected situations in 2001 to that in 2005?
Give a very brief answer. 0.43. What is the ratio of the Aid flow (current US$) in Cuba in 2001 to that in 2005?
Your answer should be very brief. 0.87. What is the ratio of the Aid flow (current US$) of Malawi in 2001 to that in 2005?
Offer a very short reply. 0.12. What is the ratio of the Aid flow (current US$) in European Union in 2001 to that in 2006?
Keep it short and to the point. 8.75. What is the ratio of the Aid flow (current US$) in Fragile and conflict affected situations in 2001 to that in 2006?
Your response must be concise. 0.21. What is the ratio of the Aid flow (current US$) of Cuba in 2001 to that in 2006?
Your answer should be very brief. 0.88. What is the ratio of the Aid flow (current US$) of Malawi in 2001 to that in 2006?
Your response must be concise. 0.13. What is the ratio of the Aid flow (current US$) in European Union in 2001 to that in 2007?
Provide a succinct answer. 7.25. What is the ratio of the Aid flow (current US$) of Fragile and conflict affected situations in 2001 to that in 2007?
Provide a short and direct response. 0.31. What is the ratio of the Aid flow (current US$) in Cuba in 2001 to that in 2007?
Give a very brief answer. 7.36. What is the ratio of the Aid flow (current US$) in Malawi in 2001 to that in 2007?
Provide a short and direct response. 0.11. What is the ratio of the Aid flow (current US$) of European Union in 2002 to that in 2003?
Provide a short and direct response. 1.11. What is the ratio of the Aid flow (current US$) of Fragile and conflict affected situations in 2002 to that in 2003?
Your response must be concise. 0.4. What is the ratio of the Aid flow (current US$) of Cuba in 2002 to that in 2003?
Give a very brief answer. 0.73. What is the ratio of the Aid flow (current US$) in Malawi in 2002 to that in 2003?
Provide a short and direct response. 0.55. What is the ratio of the Aid flow (current US$) of European Union in 2002 to that in 2004?
Provide a short and direct response. 1.19. What is the ratio of the Aid flow (current US$) of Fragile and conflict affected situations in 2002 to that in 2004?
Give a very brief answer. 0.51. What is the ratio of the Aid flow (current US$) of Cuba in 2002 to that in 2004?
Provide a succinct answer. 0.71. What is the ratio of the Aid flow (current US$) of Malawi in 2002 to that in 2004?
Your answer should be very brief. 0.48. What is the ratio of the Aid flow (current US$) of European Union in 2002 to that in 2005?
Provide a short and direct response. 6.08. What is the ratio of the Aid flow (current US$) in Fragile and conflict affected situations in 2002 to that in 2005?
Give a very brief answer. 0.49. What is the ratio of the Aid flow (current US$) in Cuba in 2002 to that in 2005?
Provide a short and direct response. 2.03. What is the ratio of the Aid flow (current US$) in Malawi in 2002 to that in 2005?
Your answer should be compact. 0.4. What is the ratio of the Aid flow (current US$) of European Union in 2002 to that in 2006?
Offer a terse response. 6.75. What is the ratio of the Aid flow (current US$) of Fragile and conflict affected situations in 2002 to that in 2006?
Offer a terse response. 0.23. What is the ratio of the Aid flow (current US$) of Cuba in 2002 to that in 2006?
Offer a very short reply. 2.05. What is the ratio of the Aid flow (current US$) of Malawi in 2002 to that in 2006?
Provide a succinct answer. 0.44. What is the ratio of the Aid flow (current US$) of European Union in 2002 to that in 2007?
Offer a very short reply. 5.6. What is the ratio of the Aid flow (current US$) of Fragile and conflict affected situations in 2002 to that in 2007?
Make the answer very short. 0.36. What is the ratio of the Aid flow (current US$) in Cuba in 2002 to that in 2007?
Your response must be concise. 17.18. What is the ratio of the Aid flow (current US$) of Malawi in 2002 to that in 2007?
Provide a succinct answer. 0.37. What is the ratio of the Aid flow (current US$) in European Union in 2003 to that in 2004?
Offer a very short reply. 1.07. What is the ratio of the Aid flow (current US$) in Fragile and conflict affected situations in 2003 to that in 2004?
Make the answer very short. 1.29. What is the ratio of the Aid flow (current US$) in Cuba in 2003 to that in 2004?
Ensure brevity in your answer.  0.97. What is the ratio of the Aid flow (current US$) in Malawi in 2003 to that in 2004?
Keep it short and to the point. 0.88. What is the ratio of the Aid flow (current US$) of European Union in 2003 to that in 2005?
Keep it short and to the point. 5.46. What is the ratio of the Aid flow (current US$) of Fragile and conflict affected situations in 2003 to that in 2005?
Your answer should be very brief. 1.22. What is the ratio of the Aid flow (current US$) of Cuba in 2003 to that in 2005?
Your answer should be compact. 2.77. What is the ratio of the Aid flow (current US$) in Malawi in 2003 to that in 2005?
Your response must be concise. 0.72. What is the ratio of the Aid flow (current US$) of European Union in 2003 to that in 2006?
Give a very brief answer. 6.07. What is the ratio of the Aid flow (current US$) of Fragile and conflict affected situations in 2003 to that in 2006?
Offer a terse response. 0.59. What is the ratio of the Aid flow (current US$) of Cuba in 2003 to that in 2006?
Your answer should be very brief. 2.8. What is the ratio of the Aid flow (current US$) of Malawi in 2003 to that in 2006?
Your answer should be very brief. 0.8. What is the ratio of the Aid flow (current US$) of European Union in 2003 to that in 2007?
Offer a terse response. 5.03. What is the ratio of the Aid flow (current US$) in Fragile and conflict affected situations in 2003 to that in 2007?
Provide a succinct answer. 0.9. What is the ratio of the Aid flow (current US$) of Cuba in 2003 to that in 2007?
Offer a terse response. 23.45. What is the ratio of the Aid flow (current US$) in Malawi in 2003 to that in 2007?
Your answer should be compact. 0.68. What is the ratio of the Aid flow (current US$) of European Union in 2004 to that in 2005?
Give a very brief answer. 5.11. What is the ratio of the Aid flow (current US$) of Fragile and conflict affected situations in 2004 to that in 2005?
Provide a succinct answer. 0.95. What is the ratio of the Aid flow (current US$) of Cuba in 2004 to that in 2005?
Your answer should be compact. 2.86. What is the ratio of the Aid flow (current US$) of Malawi in 2004 to that in 2005?
Ensure brevity in your answer.  0.82. What is the ratio of the Aid flow (current US$) of European Union in 2004 to that in 2006?
Your answer should be very brief. 5.68. What is the ratio of the Aid flow (current US$) in Fragile and conflict affected situations in 2004 to that in 2006?
Offer a very short reply. 0.46. What is the ratio of the Aid flow (current US$) of Cuba in 2004 to that in 2006?
Keep it short and to the point. 2.89. What is the ratio of the Aid flow (current US$) in Malawi in 2004 to that in 2006?
Your answer should be compact. 0.91. What is the ratio of the Aid flow (current US$) in European Union in 2004 to that in 2007?
Make the answer very short. 4.71. What is the ratio of the Aid flow (current US$) in Fragile and conflict affected situations in 2004 to that in 2007?
Provide a short and direct response. 0.7. What is the ratio of the Aid flow (current US$) in Cuba in 2004 to that in 2007?
Make the answer very short. 24.18. What is the ratio of the Aid flow (current US$) in Malawi in 2004 to that in 2007?
Offer a terse response. 0.78. What is the ratio of the Aid flow (current US$) of European Union in 2005 to that in 2006?
Your answer should be very brief. 1.11. What is the ratio of the Aid flow (current US$) in Fragile and conflict affected situations in 2005 to that in 2006?
Offer a terse response. 0.48. What is the ratio of the Aid flow (current US$) in Cuba in 2005 to that in 2006?
Give a very brief answer. 1.01. What is the ratio of the Aid flow (current US$) in Malawi in 2005 to that in 2006?
Your answer should be very brief. 1.11. What is the ratio of the Aid flow (current US$) of European Union in 2005 to that in 2007?
Offer a very short reply. 0.92. What is the ratio of the Aid flow (current US$) in Fragile and conflict affected situations in 2005 to that in 2007?
Keep it short and to the point. 0.73. What is the ratio of the Aid flow (current US$) in Cuba in 2005 to that in 2007?
Offer a very short reply. 8.45. What is the ratio of the Aid flow (current US$) in Malawi in 2005 to that in 2007?
Give a very brief answer. 0.94. What is the ratio of the Aid flow (current US$) of European Union in 2006 to that in 2007?
Ensure brevity in your answer.  0.83. What is the ratio of the Aid flow (current US$) in Fragile and conflict affected situations in 2006 to that in 2007?
Offer a very short reply. 1.52. What is the ratio of the Aid flow (current US$) in Cuba in 2006 to that in 2007?
Your response must be concise. 8.36. What is the ratio of the Aid flow (current US$) in Malawi in 2006 to that in 2007?
Offer a very short reply. 0.85. What is the difference between the highest and the second highest Aid flow (current US$) of European Union?
Your response must be concise. 1.01e+07. What is the difference between the highest and the second highest Aid flow (current US$) of Fragile and conflict affected situations?
Make the answer very short. 2.15e+08. What is the difference between the highest and the second highest Aid flow (current US$) in Malawi?
Your response must be concise. 1.14e+06. What is the difference between the highest and the lowest Aid flow (current US$) of European Union?
Your response must be concise. 3.92e+07. What is the difference between the highest and the lowest Aid flow (current US$) in Fragile and conflict affected situations?
Provide a succinct answer. 4.97e+08. What is the difference between the highest and the lowest Aid flow (current US$) in Cuba?
Offer a very short reply. 2.55e+06. What is the difference between the highest and the lowest Aid flow (current US$) in Malawi?
Provide a short and direct response. 1.82e+07. 